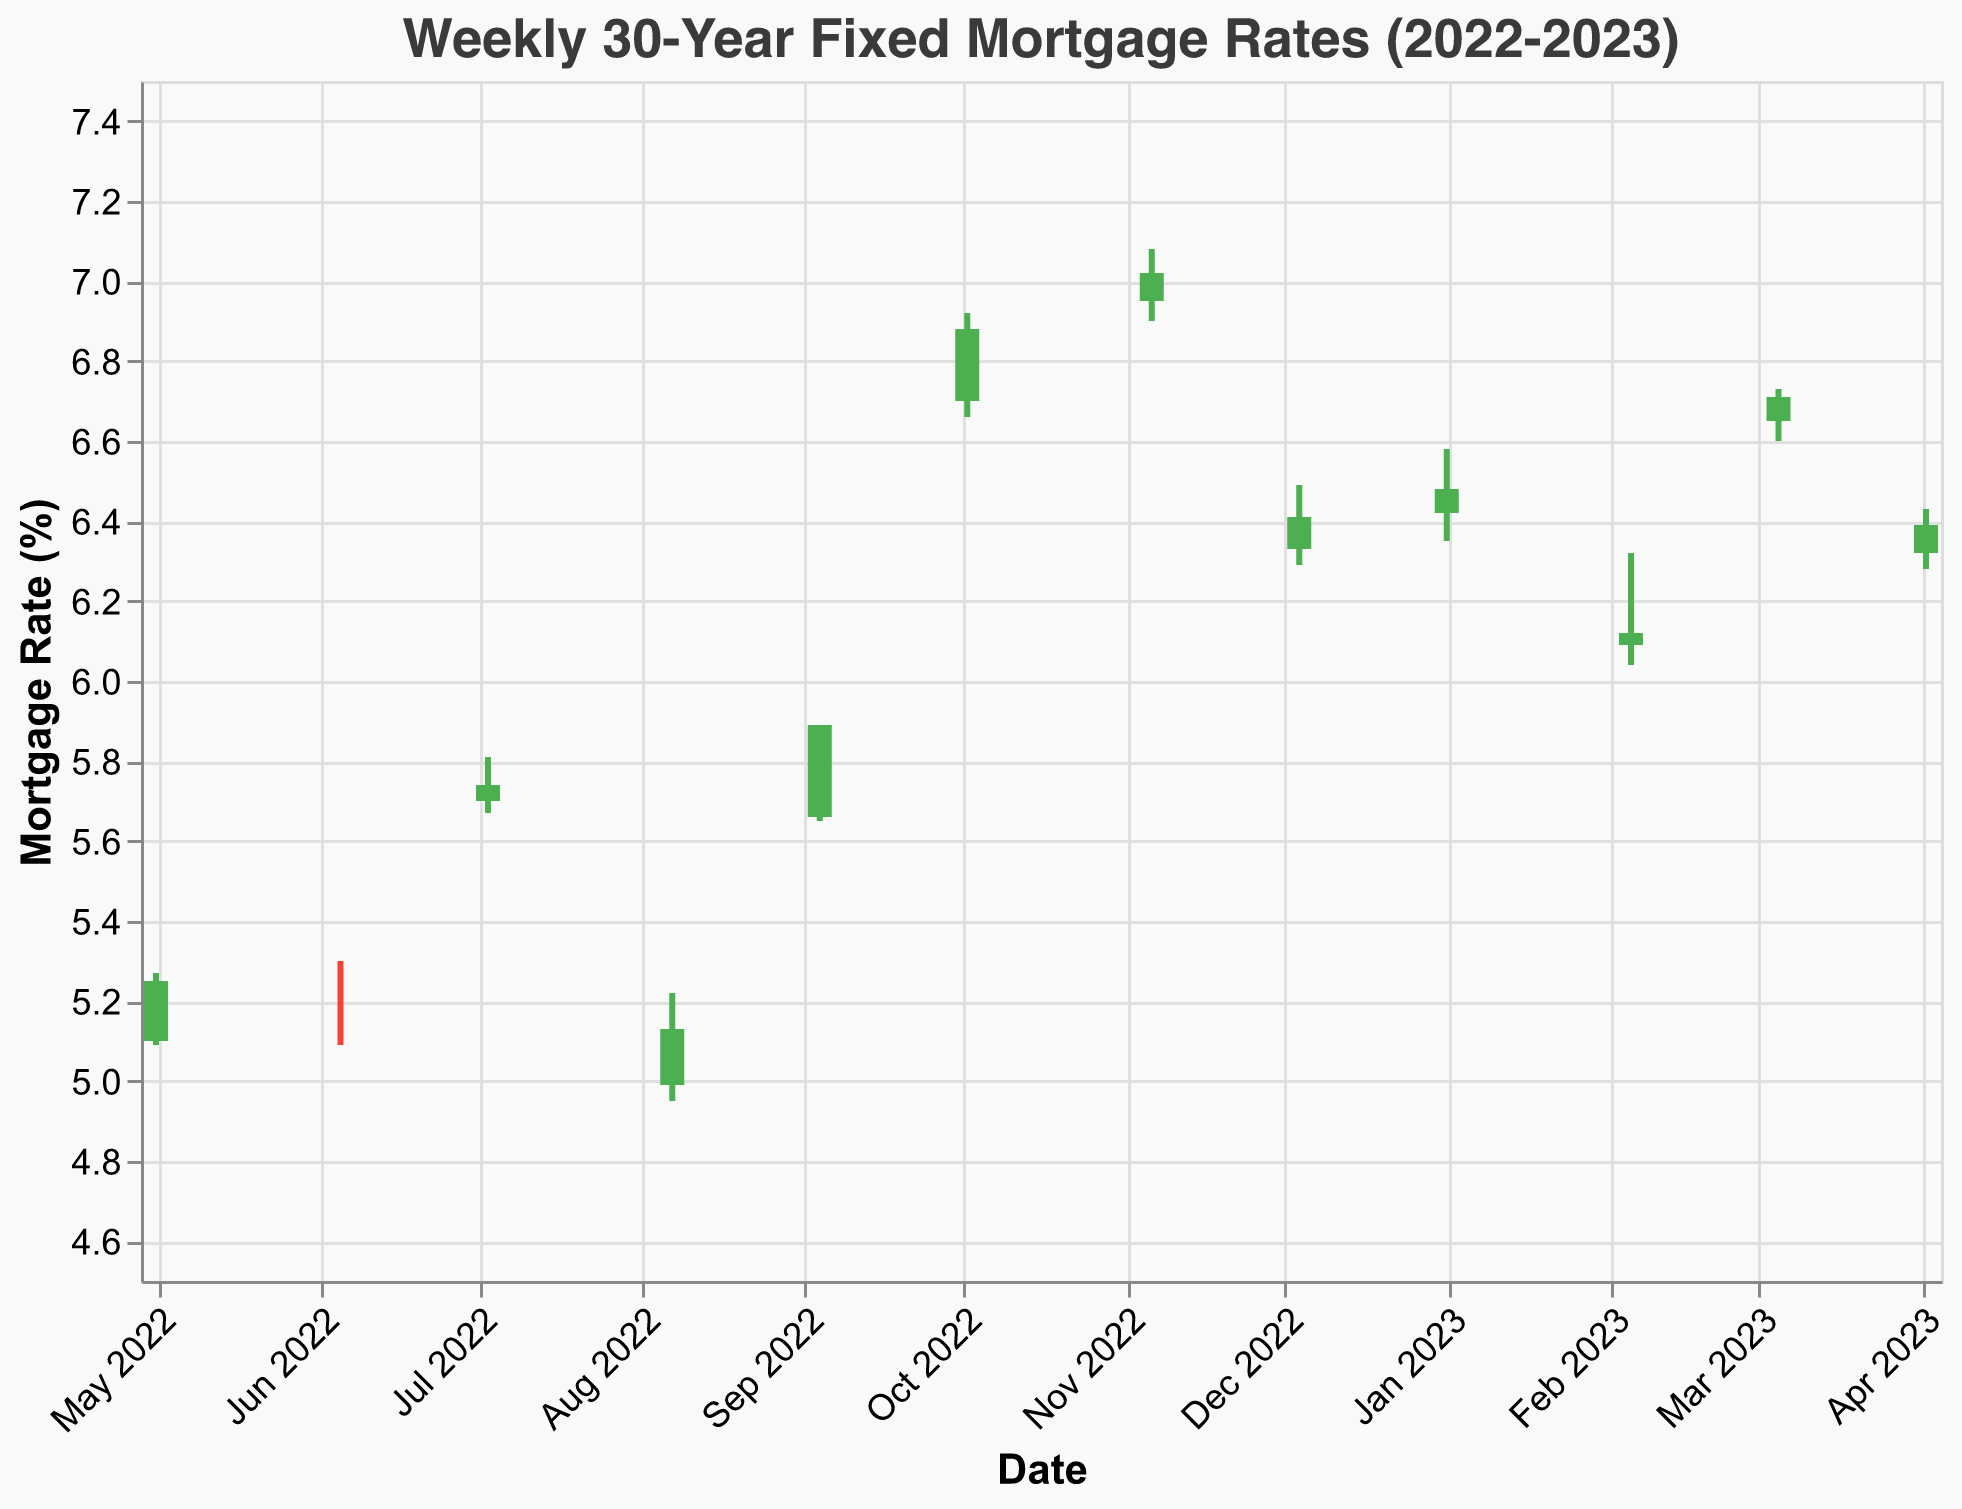What is the title of the figure? The title of the figure is written at the top and states "Weekly 30-Year Fixed Mortgage Rates (2022-2023)"
Answer: Weekly 30-Year Fixed Mortgage Rates (2022-2023) How many data points are there in the figure? By counting the number of bars or data entries in the figure, we can determine that there are 12 data points
Answer: 12 Which month had the highest closing mortgage rate? By identifying the highest closing value among all the months, the highest closing mortgage rate is in November 2022, with a rate of 7.02%
Answer: November 2022 What was the range of mortgage rates in October 2022? The range can be calculated by finding the difference between the highest and lowest values for October 2022. The high was 6.92% and the low was 6.66%, so the range is 6.92 - 6.66 = 0.26%
Answer: 0.26% Which month showed a decreasing trend in mortgage rates? A decreasing trend can be identified where the opening rate is higher than the closing rate. In August 2022, the rate opened at 4.99% and closed at 5.13%, indicating an overall increase. Upon careful examination, February 2023 shows a decreasing trend with an opening of 6.09% and closing of 6.12%
Answer: February 2023 When was the largest difference between the high and low mortgage rate in a single month? The largest difference can be found by examining each month's high and low values and calculating the difference. In October 2022, the difference was greatest with the high at 6.92% and the low at 6.66%, resulting in a 0.26% difference
Answer: October 2022 How did the mortgage rate change from December 2022 to January 2023? Compare the closing values of December 2022 and January 2023. In December 2022, the closing rate was 6.41% and in January 2023, it was 6.48%, showing an increase
Answer: Increased Which month had the smallest difference between the open and close mortgage rate? Calculate the difference between the open and close rates for each month. June 2022 had the smallest difference with the open rate at 5.23% and the close rate at 5.23%, resulting in a 0% difference
Answer: June 2022 What was the closing mortgage rate in March 2023? The closing rate for March 2023 can be directly read from the data, which is 6.71%
Answer: 6.71% What color signifies an increase in mortgage rate in this OHLC chart? In this OHLC chart, an increase in the mortgage rate is signified by a green color
Answer: Green 